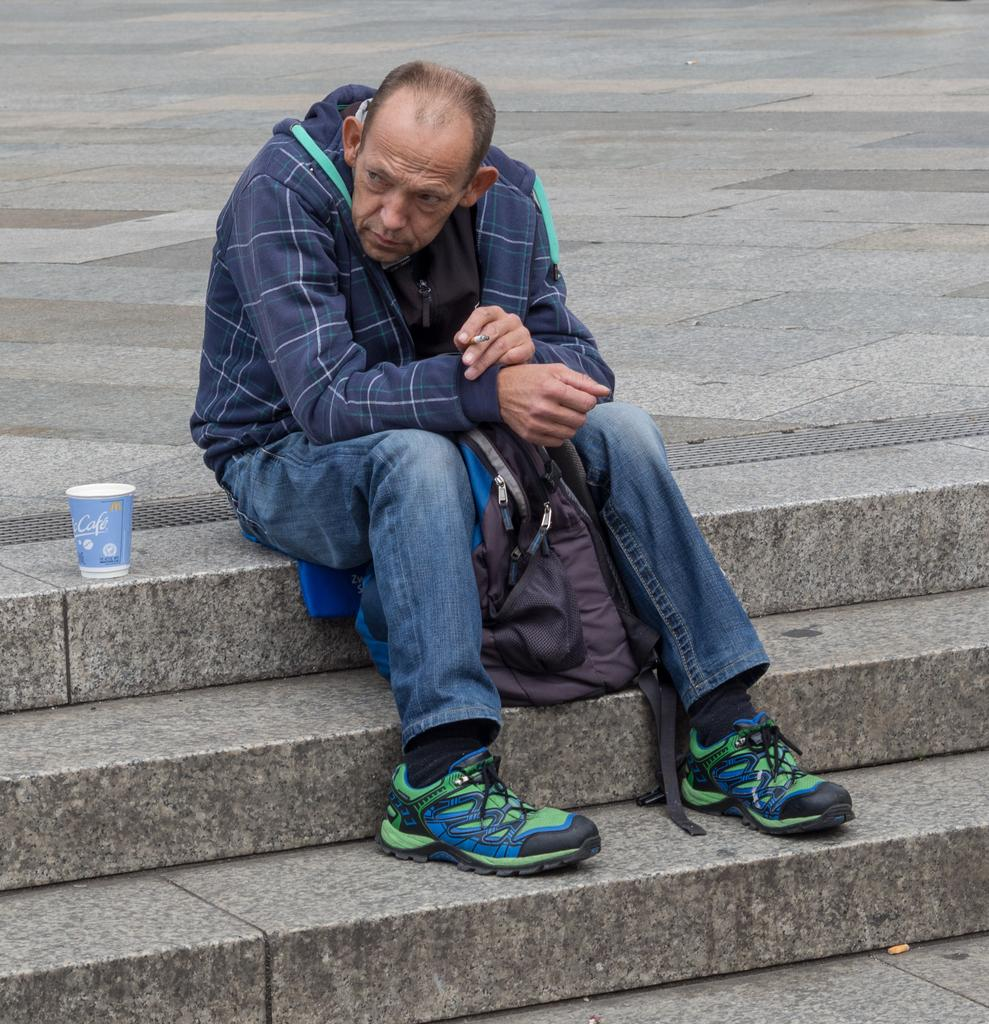What is the person in the image doing? The person is sitting in the image. What is the person holding in the image? The person is holding a cigarette. What other objects can be seen in the image? There is a bag and a cup in the image. What architectural feature is visible in the image? The stairs are visible in the image. What is the surface on which the person is sitting? The ground is visible in the image. Can you see a tiger walking in the image? No, there is no tiger present in the image. What type of cloud can be seen in the image? There are no clouds visible in the image. 